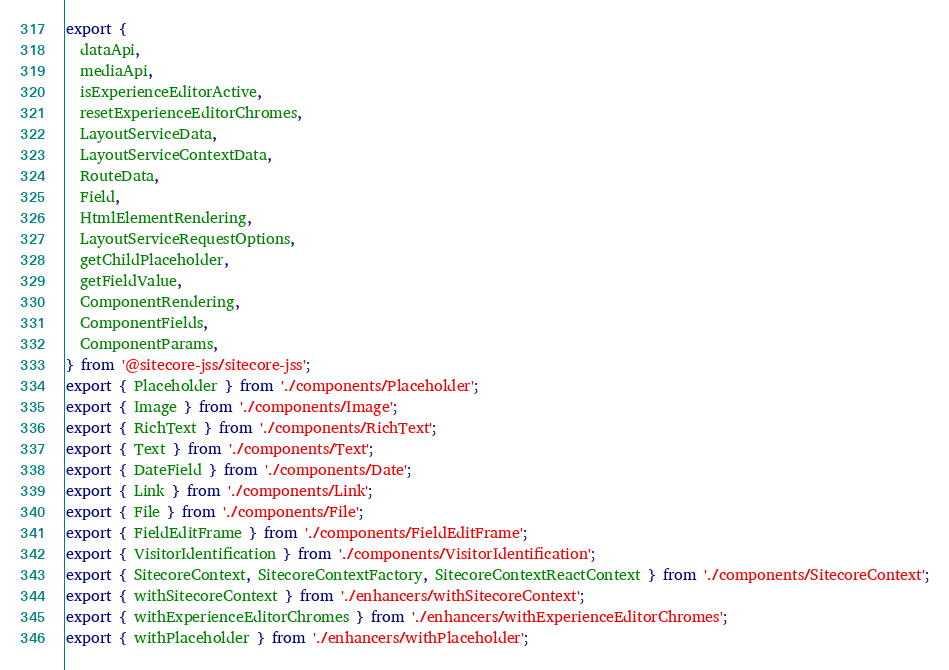Convert code to text. <code><loc_0><loc_0><loc_500><loc_500><_TypeScript_>export {
  dataApi,
  mediaApi,
  isExperienceEditorActive,
  resetExperienceEditorChromes,
  LayoutServiceData,
  LayoutServiceContextData,
  RouteData,
  Field,
  HtmlElementRendering,
  LayoutServiceRequestOptions,
  getChildPlaceholder,
  getFieldValue,
  ComponentRendering,
  ComponentFields,
  ComponentParams,
} from '@sitecore-jss/sitecore-jss';
export { Placeholder } from './components/Placeholder';
export { Image } from './components/Image';
export { RichText } from './components/RichText';
export { Text } from './components/Text';
export { DateField } from './components/Date';
export { Link } from './components/Link';
export { File } from './components/File';
export { FieldEditFrame } from './components/FieldEditFrame';
export { VisitorIdentification } from './components/VisitorIdentification';
export { SitecoreContext, SitecoreContextFactory, SitecoreContextReactContext } from './components/SitecoreContext';
export { withSitecoreContext } from './enhancers/withSitecoreContext';
export { withExperienceEditorChromes } from './enhancers/withExperienceEditorChromes';
export { withPlaceholder } from './enhancers/withPlaceholder';
</code> 